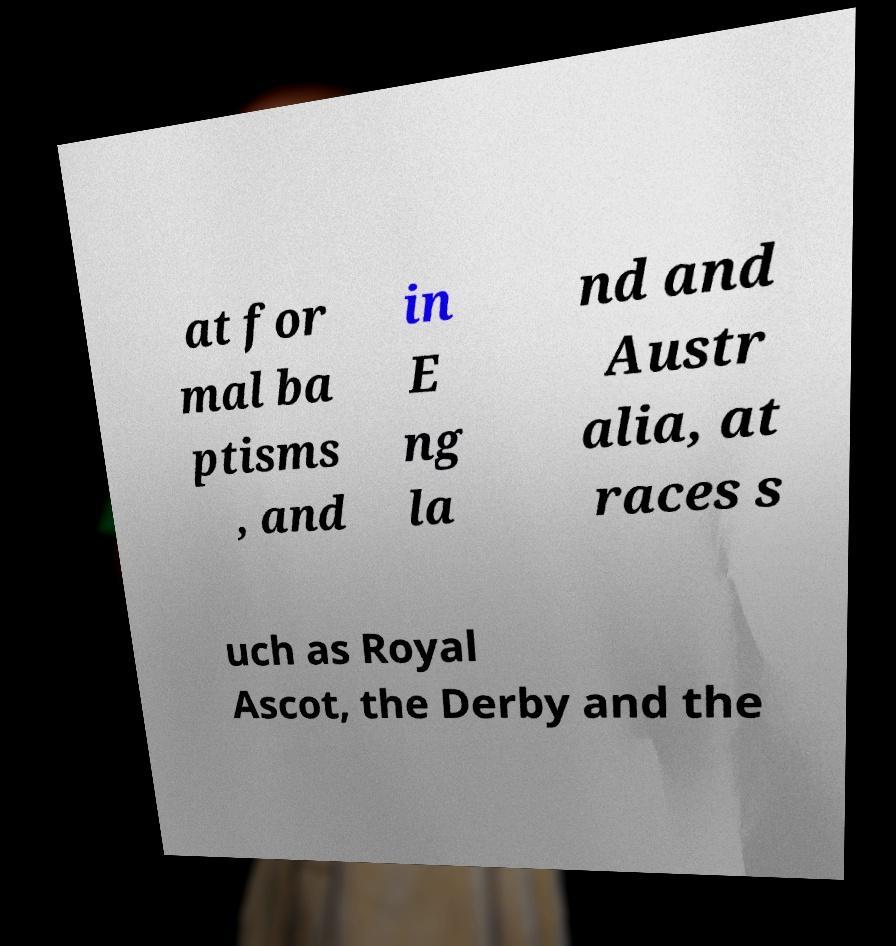I need the written content from this picture converted into text. Can you do that? at for mal ba ptisms , and in E ng la nd and Austr alia, at races s uch as Royal Ascot, the Derby and the 